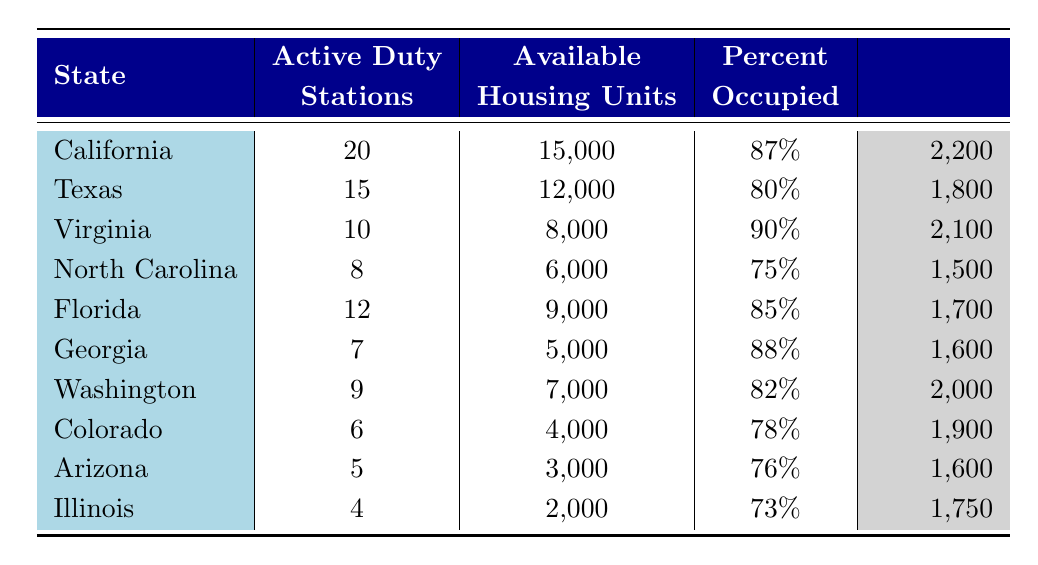What state has the highest average rent? The table lists the average rent for each state. California has an average rent of 2200, which is higher than any other state on the list.
Answer: California Which state has the lowest percentage of occupied housing? By examining the "Percent Occupied" column, Illinois has the lowest value at 73%.
Answer: Illinois What is the total number of available housing units in Texas and Florida combined? Texas has 12000 available housing units and Florida has 9000. Adding these two values (12000 + 9000) gives us a total of 21000 available housing units.
Answer: 21000 How many active duty stations are there in Virginia compared to Arizona? Virginia has 10 active duty stations, whereas Arizona has 5. Comparing these two values shows that Virginia has 5 more active duty stations than Arizona.
Answer: Virginia has 5 more active duty stations Is the average rent in North Carolina less than that in Georgia? The average rent for North Carolina is 1500 while for Georgia it is 1600. Since 1500 < 1600, the statement is true.
Answer: Yes What is the percentage of occupied housing units in California and how does it compare to the percentage in Colorado? California has 87% occupied housing units and Colorado has 78%. Comparing the two, California's housing occupancy is 9% higher than Colorado's.
Answer: California is 9% higher What is the average rent across all states listed in the table? To find the average rent, we sum the average rents (2200 + 1800 + 2100 + 1500 + 1700 + 1600 + 2000 + 1900 + 1600 + 1750) which equals  18750. Then we divide this sum by the number of states (10) resulting in an average rent of 1875.
Answer: 1875 Which state has more active duty stations, California or North Carolina? California has 20 active duty stations while North Carolina has 8. Therefore, California has more active duty stations than North Carolina.
Answer: California Are there more than 7000 available housing units in Washington? The table shows that Washington has 7000 available housing units. Since the question asks if it's more than 7000, the answer is no.
Answer: No 